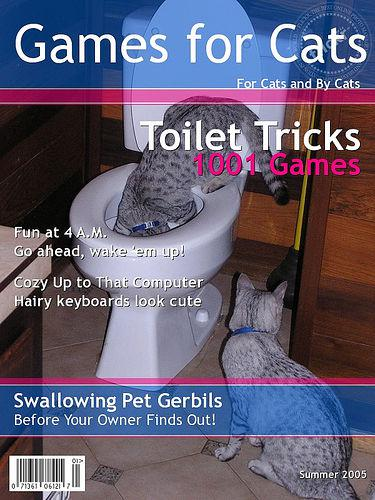Question: what are they doing?
Choices:
A. Reading a book.
B. Doing a crossword puzzle.
C. Playing in the bathroom.
D. Reading the magazine.
Answer with the letter. Answer: C Question: why is the cat getting in the toilet?
Choices:
A. To get a drink.
B. To see its reflection.
C. To play with the water.
D. To get wet.
Answer with the letter. Answer: C Question: how many cats are there?
Choices:
A. Two.
B. Three.
C. Four.
D. One.
Answer with the letter. Answer: A 